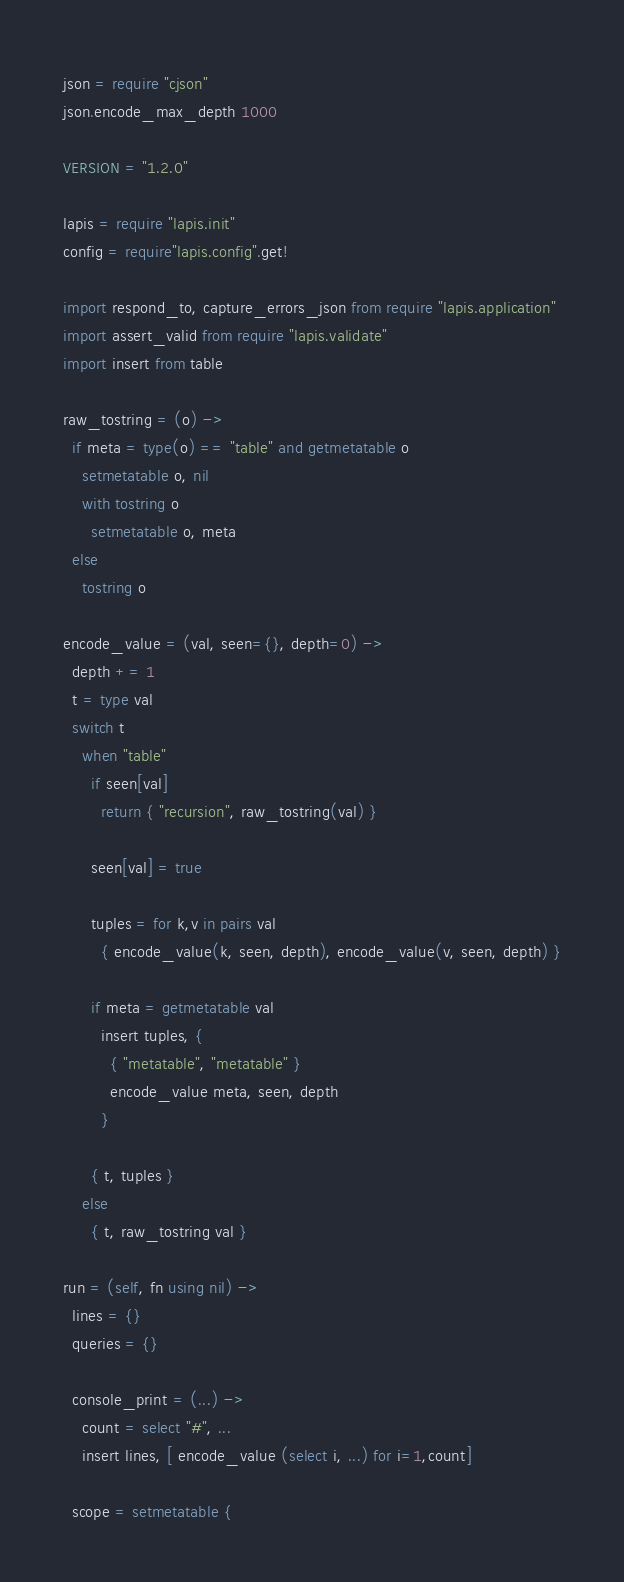Convert code to text. <code><loc_0><loc_0><loc_500><loc_500><_MoonScript_>json = require "cjson"
json.encode_max_depth 1000

VERSION = "1.2.0"

lapis = require "lapis.init"
config = require"lapis.config".get!

import respond_to, capture_errors_json from require "lapis.application"
import assert_valid from require "lapis.validate"
import insert from table

raw_tostring = (o) ->
  if meta = type(o) == "table" and getmetatable o
    setmetatable o, nil
    with tostring o
      setmetatable o, meta
  else
    tostring o

encode_value = (val, seen={}, depth=0) ->
  depth += 1
  t = type val
  switch t
    when "table"
      if seen[val]
        return { "recursion", raw_tostring(val) }

      seen[val] = true

      tuples = for k,v in pairs val
        { encode_value(k, seen, depth), encode_value(v, seen, depth) }

      if meta = getmetatable val
        insert tuples, {
          { "metatable", "metatable" }
          encode_value meta, seen, depth
        }

      { t, tuples }
    else
      { t, raw_tostring val }

run = (self, fn using nil) ->
  lines = {}
  queries = {}

  console_print = (...) ->
    count = select "#", ...
    insert lines, [ encode_value (select i, ...) for i=1,count]

  scope = setmetatable {</code> 